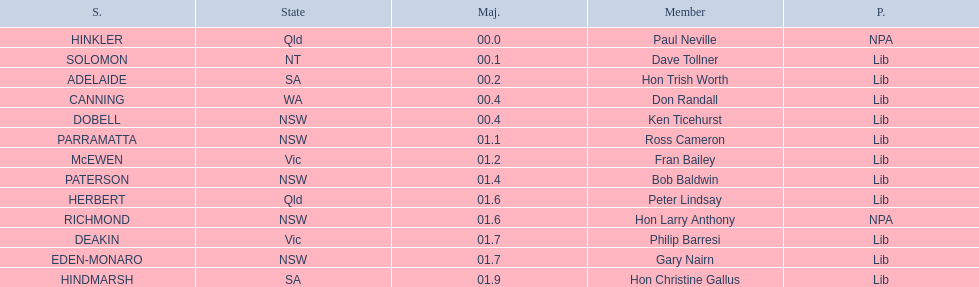Which seats are represented in the electoral system of australia? HINKLER, SOLOMON, ADELAIDE, CANNING, DOBELL, PARRAMATTA, McEWEN, PATERSON, HERBERT, RICHMOND, DEAKIN, EDEN-MONARO, HINDMARSH. What were their majority numbers of both hindmarsh and hinkler? HINKLER, HINDMARSH. Of those two seats, what is the difference in voting majority? 01.9. 